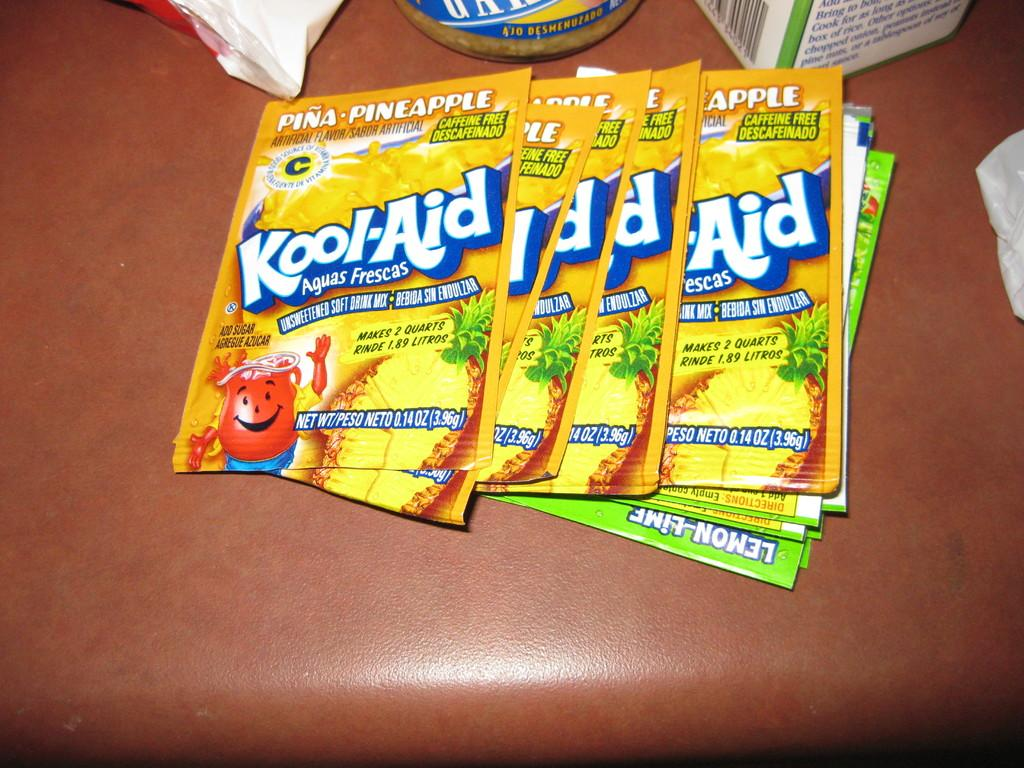What type of printed materials can be seen in the image? There are colorful pamphlets in the image. What else is present in the image that is also colorful? There are colorful boxes in the image. On what surface are the colorful boxes and pamphlets placed? The colorful boxes and pamphlets are on a brown surface. Can you see any roads or skateboards in the image? No, there are no roads or skateboards present in the image. Is there a cake visible in the image? No, there is no cake present in the image. 